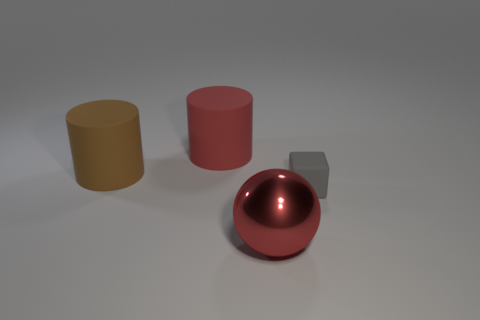Are there any other things that are the same size as the gray matte block?
Offer a very short reply. No. There is a big rubber cylinder behind the brown rubber thing; are there any gray matte things in front of it?
Give a very brief answer. Yes. How many cylinders are large red rubber things or tiny purple matte things?
Provide a short and direct response. 1. There is a cylinder to the left of the big red object that is behind the small gray block that is in front of the big brown cylinder; what is its size?
Offer a terse response. Large. There is a small gray matte cube; are there any large balls behind it?
Offer a very short reply. No. There is a object that is the same color as the sphere; what is its shape?
Provide a succinct answer. Cylinder. How many objects are matte cylinders behind the large brown cylinder or big cylinders?
Provide a short and direct response. 2. There is a brown thing that is made of the same material as the block; what size is it?
Provide a short and direct response. Large. Is the size of the red metal ball the same as the red object that is behind the large shiny ball?
Offer a very short reply. Yes. What color is the thing that is in front of the big brown rubber thing and left of the tiny matte cube?
Offer a very short reply. Red. 